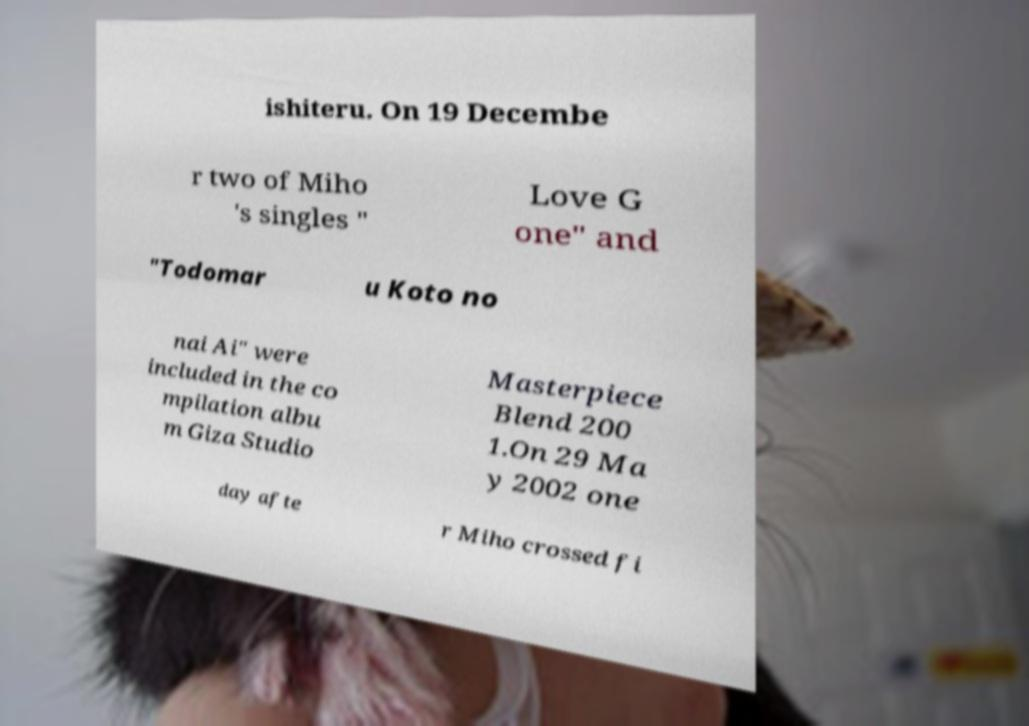Can you accurately transcribe the text from the provided image for me? ishiteru. On 19 Decembe r two of Miho 's singles " Love G one" and "Todomar u Koto no nai Ai" were included in the co mpilation albu m Giza Studio Masterpiece Blend 200 1.On 29 Ma y 2002 one day afte r Miho crossed fi 